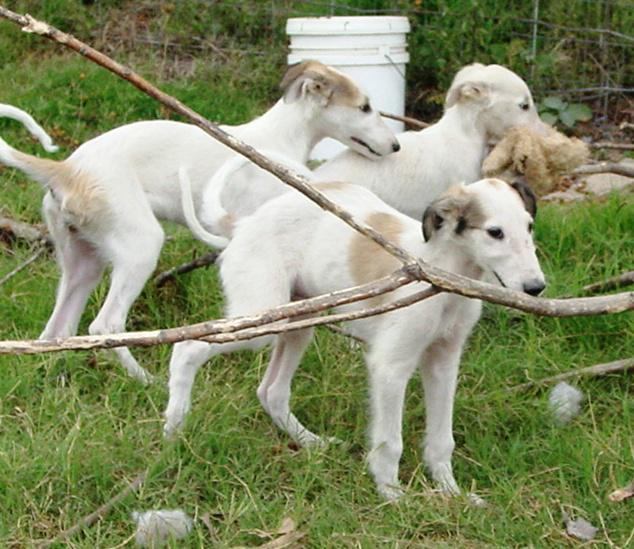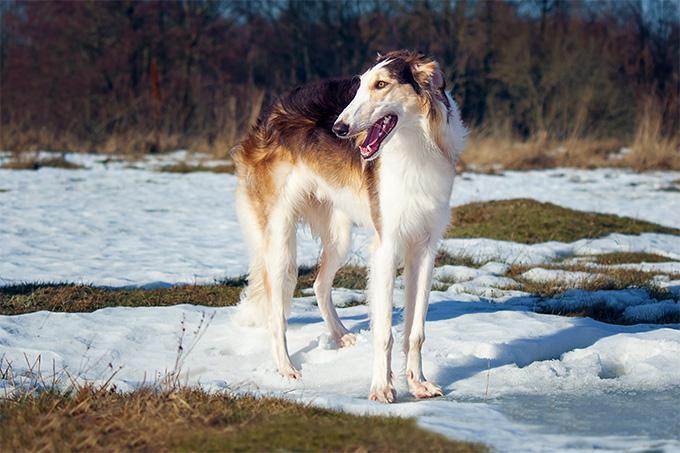The first image is the image on the left, the second image is the image on the right. Given the left and right images, does the statement "One of the images contains exactly three dogs." hold true? Answer yes or no. Yes. 